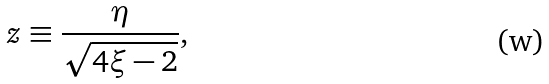Convert formula to latex. <formula><loc_0><loc_0><loc_500><loc_500>z \equiv \frac { \eta } { \sqrt { 4 \xi - 2 } } ,</formula> 